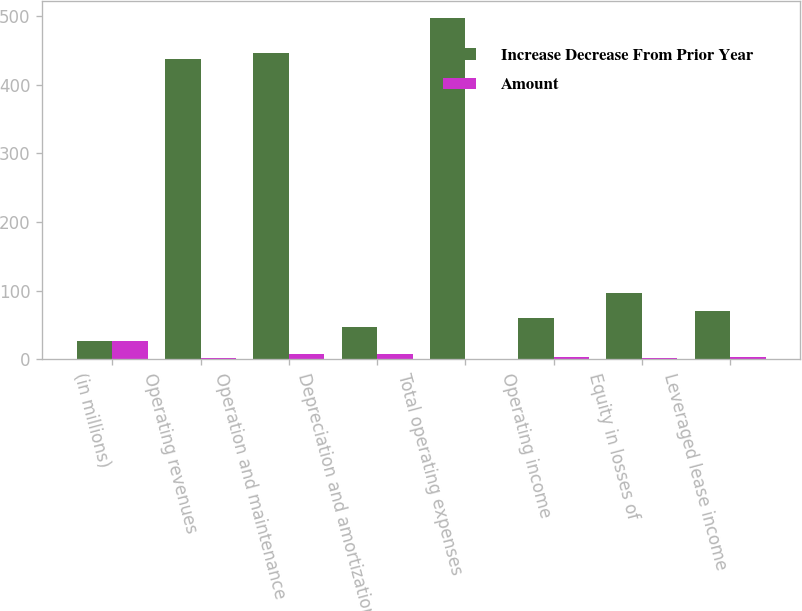Convert chart. <chart><loc_0><loc_0><loc_500><loc_500><stacked_bar_chart><ecel><fcel>(in millions)<fcel>Operating revenues<fcel>Operation and maintenance<fcel>Depreciation and amortization<fcel>Total operating expenses<fcel>Operating income<fcel>Equity in losses of<fcel>Leveraged lease income<nl><fcel>Increase Decrease From Prior Year<fcel>27.5<fcel>437<fcel>447<fcel>47<fcel>497<fcel>60<fcel>97<fcel>70<nl><fcel>Amount<fcel>27.5<fcel>2<fcel>8<fcel>8<fcel>1<fcel>3<fcel>2<fcel>4<nl></chart> 